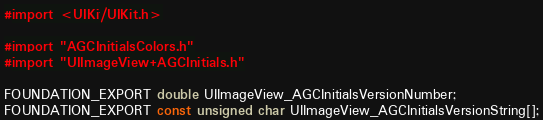<code> <loc_0><loc_0><loc_500><loc_500><_C_>#import <UIKit/UIKit.h>

#import "AGCInitialsColors.h"
#import "UIImageView+AGCInitials.h"

FOUNDATION_EXPORT double UIImageView_AGCInitialsVersionNumber;
FOUNDATION_EXPORT const unsigned char UIImageView_AGCInitialsVersionString[];

</code> 